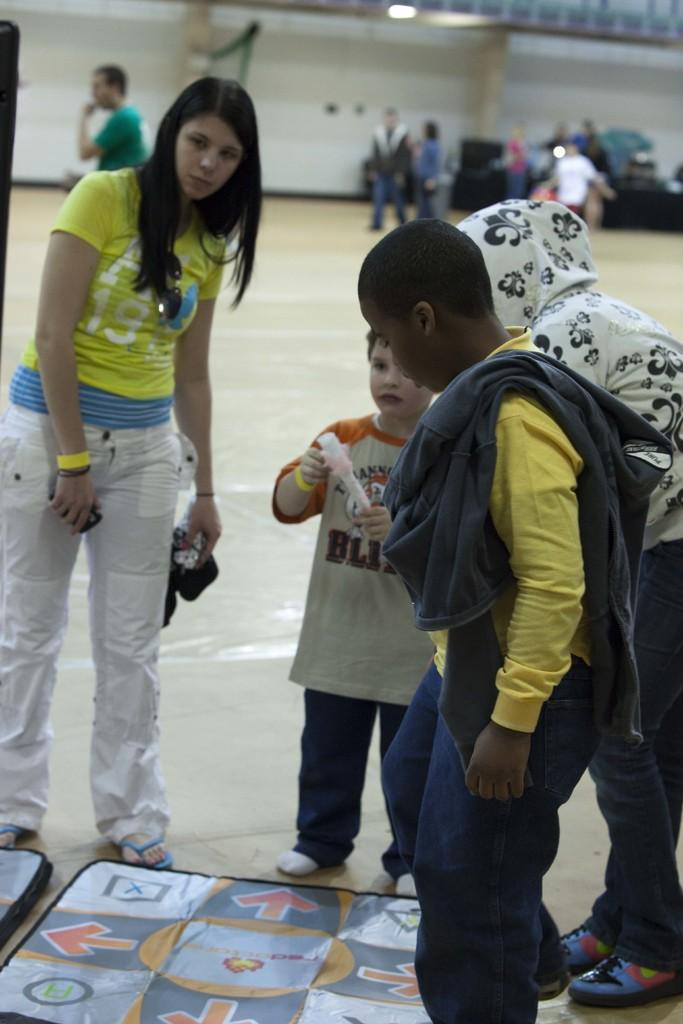What is the setting of the image? People are standing in a hall. What is the child doing in the image? A child is holding an object. Can you describe the position of the other people in the image? There are other people at the back. What type of cream is being used by the people in the image? There is no cream visible or mentioned in the image. Is there a throne present in the image? There is no throne present in the image. 